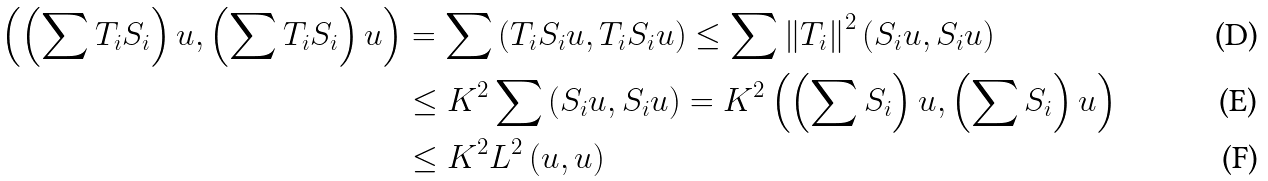<formula> <loc_0><loc_0><loc_500><loc_500>\left ( \left ( \sum T _ { i } S _ { i } \right ) u , \left ( \sum T _ { i } S _ { i } \right ) u \right ) & = \sum \left ( T _ { i } S _ { i } u , T _ { i } S _ { i } u \right ) \leq \sum \left \| T _ { i } \right \| ^ { 2 } \left ( S _ { i } u , S _ { i } u \right ) \\ & \leq K ^ { 2 } \sum \left ( S _ { i } u , S _ { i } u \right ) = K ^ { 2 } \left ( \left ( \sum S _ { i } \right ) u , \left ( \sum S _ { i } \right ) u \right ) \\ & \leq K ^ { 2 } L ^ { 2 } \left ( u , u \right )</formula> 